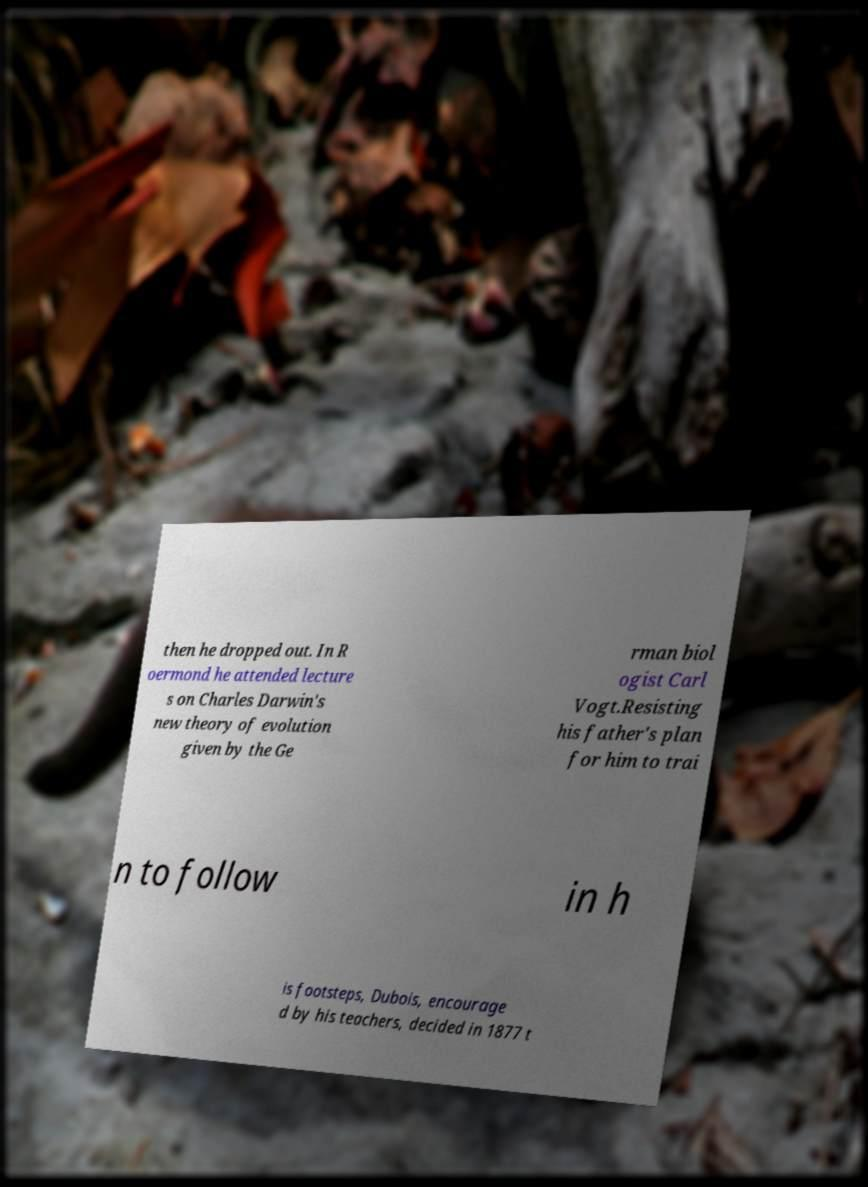Please identify and transcribe the text found in this image. then he dropped out. In R oermond he attended lecture s on Charles Darwin's new theory of evolution given by the Ge rman biol ogist Carl Vogt.Resisting his father's plan for him to trai n to follow in h is footsteps, Dubois, encourage d by his teachers, decided in 1877 t 